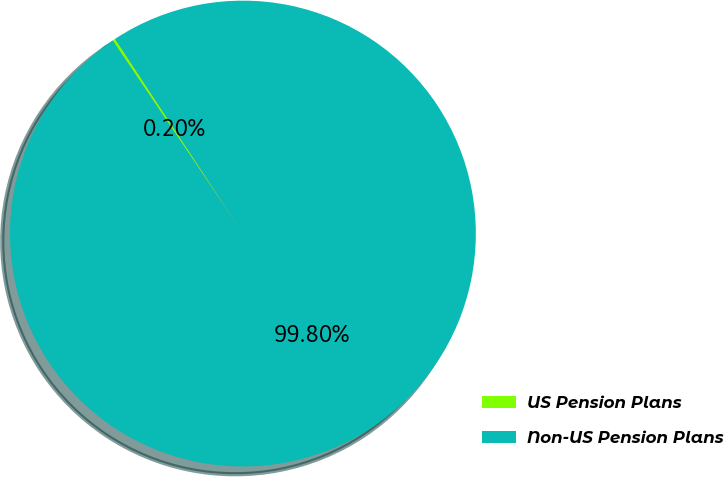Convert chart to OTSL. <chart><loc_0><loc_0><loc_500><loc_500><pie_chart><fcel>US Pension Plans<fcel>Non-US Pension Plans<nl><fcel>0.2%<fcel>99.8%<nl></chart> 